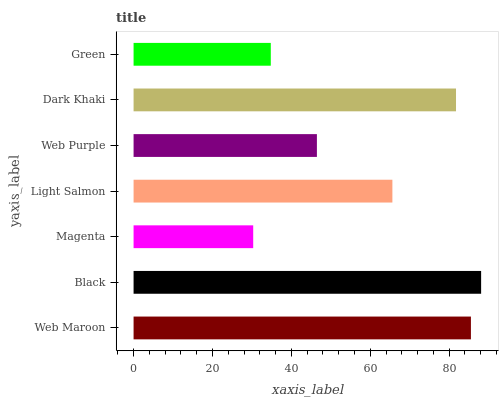Is Magenta the minimum?
Answer yes or no. Yes. Is Black the maximum?
Answer yes or no. Yes. Is Black the minimum?
Answer yes or no. No. Is Magenta the maximum?
Answer yes or no. No. Is Black greater than Magenta?
Answer yes or no. Yes. Is Magenta less than Black?
Answer yes or no. Yes. Is Magenta greater than Black?
Answer yes or no. No. Is Black less than Magenta?
Answer yes or no. No. Is Light Salmon the high median?
Answer yes or no. Yes. Is Light Salmon the low median?
Answer yes or no. Yes. Is Magenta the high median?
Answer yes or no. No. Is Magenta the low median?
Answer yes or no. No. 